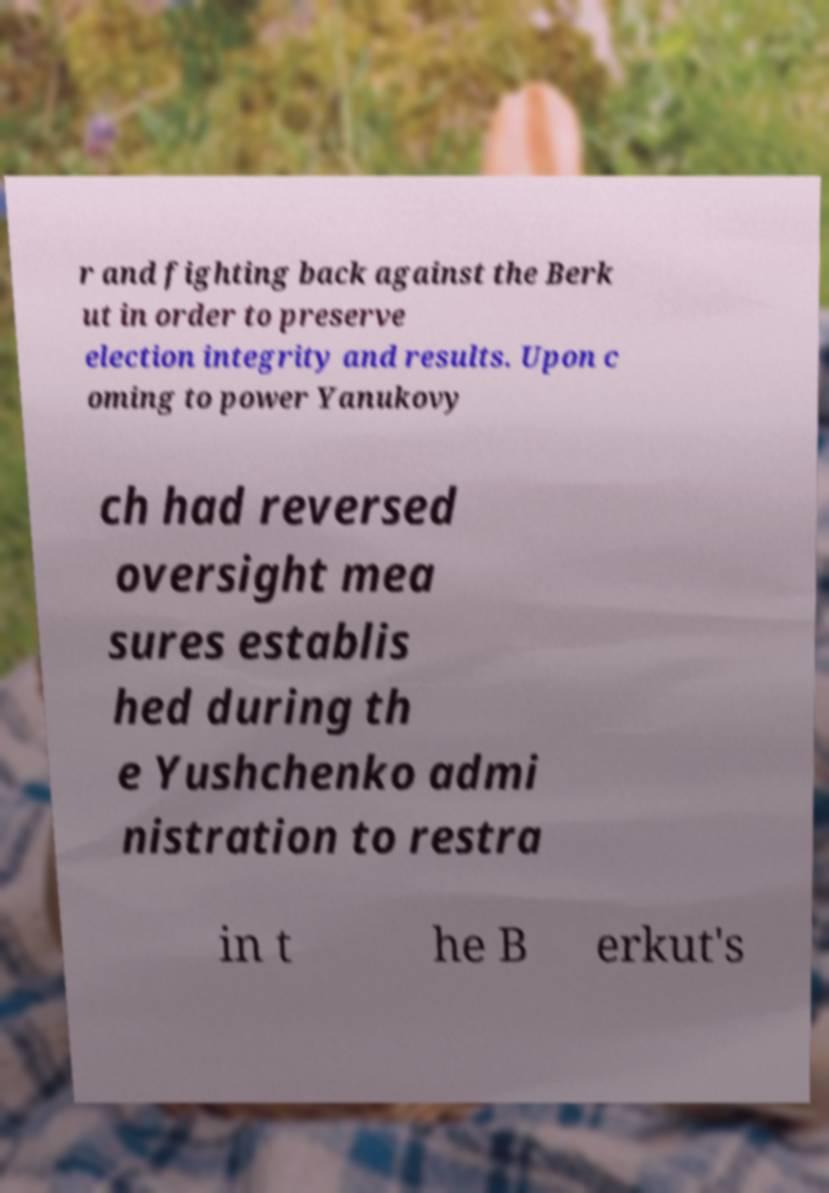Could you assist in decoding the text presented in this image and type it out clearly? r and fighting back against the Berk ut in order to preserve election integrity and results. Upon c oming to power Yanukovy ch had reversed oversight mea sures establis hed during th e Yushchenko admi nistration to restra in t he B erkut's 